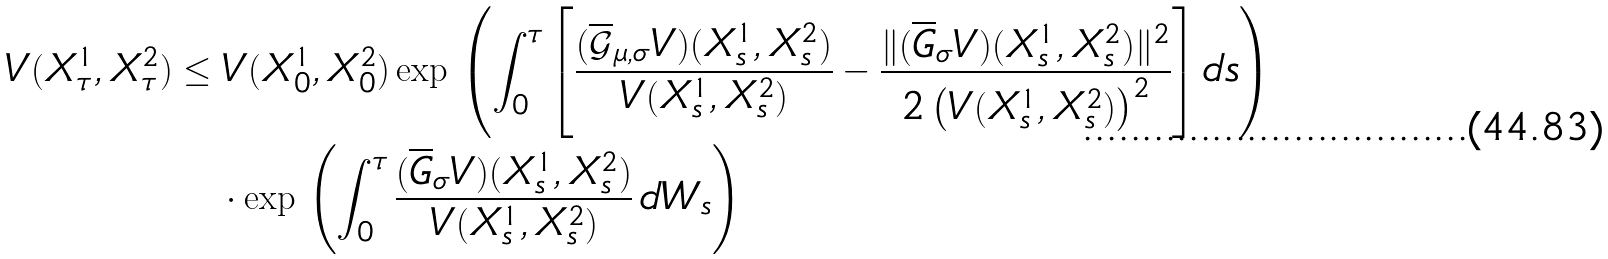Convert formula to latex. <formula><loc_0><loc_0><loc_500><loc_500>V ( X ^ { 1 } _ { \tau } , X ^ { 2 } _ { \tau } ) & \leq V ( X ^ { 1 } _ { 0 } , X ^ { 2 } _ { 0 } ) \exp \, \left ( \int _ { 0 } ^ { \tau } \left [ \frac { ( \overline { \mathcal { G } } _ { \mu , \sigma } V ) ( X _ { s } ^ { 1 } , X _ { s } ^ { 2 } ) } { V ( X _ { s } ^ { 1 } , X _ { s } ^ { 2 } ) } - \frac { \| ( \overline { G } _ { \sigma } V ) ( X ^ { 1 } _ { s } , X ^ { 2 } _ { s } ) \| ^ { 2 } } { 2 \left ( V ( X ^ { 1 } _ { s } , X ^ { 2 } _ { s } ) \right ) ^ { 2 } } \right ] d s \right ) \\ & \quad \cdot \exp \, \left ( \int _ { 0 } ^ { \tau } \frac { ( \overline { G } _ { \sigma } V ) ( X ^ { 1 } _ { s } , X ^ { 2 } _ { s } ) } { V ( X ^ { 1 } _ { s } , X ^ { 2 } _ { s } ) } \, d W _ { s } \right )</formula> 